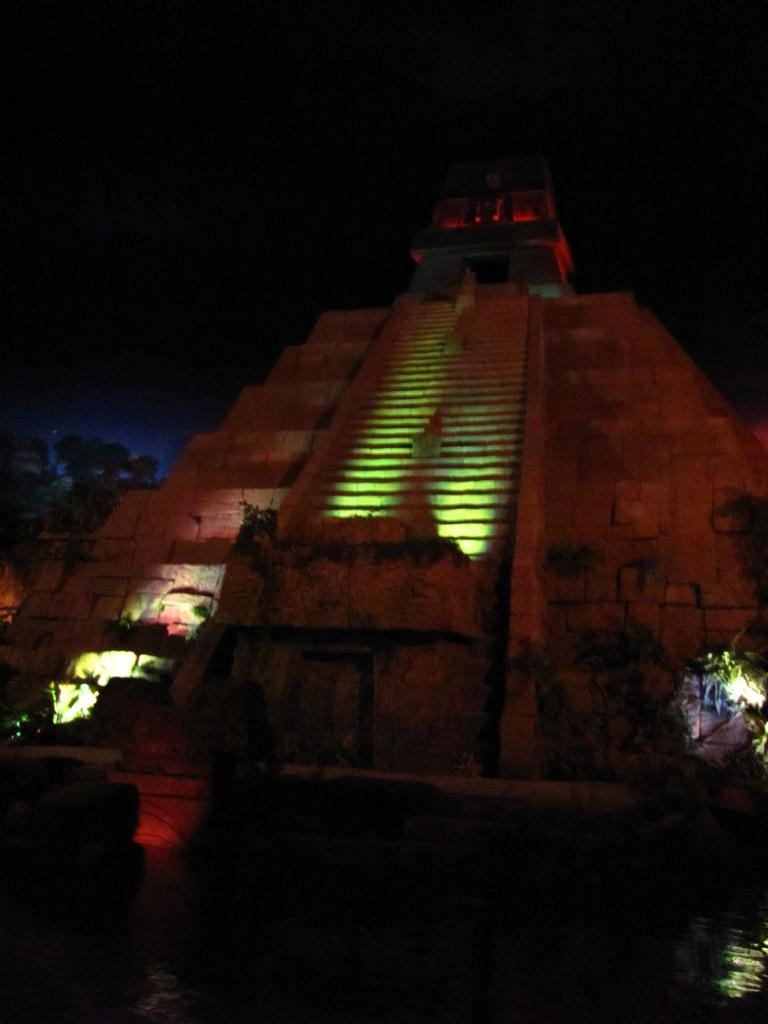What can be seen in the foreground of the image? In the foreground of the image, there is water, a pillar, lights, trees, steps, and a building. How many elements are present in the foreground of the image? There are six elements present in the foreground of the image: water, a pillar, lights, trees, steps, and a building. What is visible in the background of the image? The sky is visible in the background of the image. What can be inferred about the time of day the image was taken? The image is likely taken during the night, as there are lights visible in the foreground. How many chairs are visible in the image? There are no chairs present in the image. What type of horse can be seen interacting with the water in the image? There is no horse present in the image; it features water, a pillar, lights, trees, steps, and a building in the foreground. 